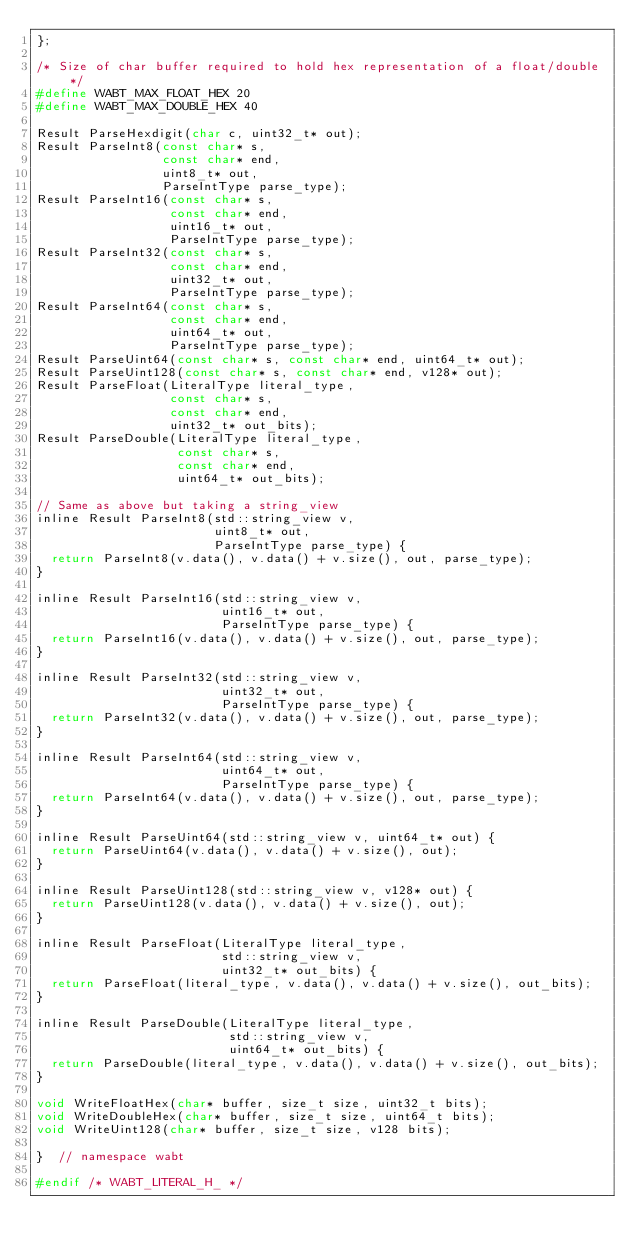Convert code to text. <code><loc_0><loc_0><loc_500><loc_500><_C_>};

/* Size of char buffer required to hold hex representation of a float/double */
#define WABT_MAX_FLOAT_HEX 20
#define WABT_MAX_DOUBLE_HEX 40

Result ParseHexdigit(char c, uint32_t* out);
Result ParseInt8(const char* s,
                 const char* end,
                 uint8_t* out,
                 ParseIntType parse_type);
Result ParseInt16(const char* s,
                  const char* end,
                  uint16_t* out,
                  ParseIntType parse_type);
Result ParseInt32(const char* s,
                  const char* end,
                  uint32_t* out,
                  ParseIntType parse_type);
Result ParseInt64(const char* s,
                  const char* end,
                  uint64_t* out,
                  ParseIntType parse_type);
Result ParseUint64(const char* s, const char* end, uint64_t* out);
Result ParseUint128(const char* s, const char* end, v128* out);
Result ParseFloat(LiteralType literal_type,
                  const char* s,
                  const char* end,
                  uint32_t* out_bits);
Result ParseDouble(LiteralType literal_type,
                   const char* s,
                   const char* end,
                   uint64_t* out_bits);

// Same as above but taking a string_view
inline Result ParseInt8(std::string_view v,
                        uint8_t* out,
                        ParseIntType parse_type) {
  return ParseInt8(v.data(), v.data() + v.size(), out, parse_type);
}

inline Result ParseInt16(std::string_view v,
                         uint16_t* out,
                         ParseIntType parse_type) {
  return ParseInt16(v.data(), v.data() + v.size(), out, parse_type);
}

inline Result ParseInt32(std::string_view v,
                         uint32_t* out,
                         ParseIntType parse_type) {
  return ParseInt32(v.data(), v.data() + v.size(), out, parse_type);
}

inline Result ParseInt64(std::string_view v,
                         uint64_t* out,
                         ParseIntType parse_type) {
  return ParseInt64(v.data(), v.data() + v.size(), out, parse_type);
}

inline Result ParseUint64(std::string_view v, uint64_t* out) {
  return ParseUint64(v.data(), v.data() + v.size(), out);
}

inline Result ParseUint128(std::string_view v, v128* out) {
  return ParseUint128(v.data(), v.data() + v.size(), out);
}

inline Result ParseFloat(LiteralType literal_type,
                         std::string_view v,
                         uint32_t* out_bits) {
  return ParseFloat(literal_type, v.data(), v.data() + v.size(), out_bits);
}

inline Result ParseDouble(LiteralType literal_type,
                          std::string_view v,
                          uint64_t* out_bits) {
  return ParseDouble(literal_type, v.data(), v.data() + v.size(), out_bits);
}

void WriteFloatHex(char* buffer, size_t size, uint32_t bits);
void WriteDoubleHex(char* buffer, size_t size, uint64_t bits);
void WriteUint128(char* buffer, size_t size, v128 bits);

}  // namespace wabt

#endif /* WABT_LITERAL_H_ */
</code> 